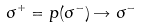Convert formula to latex. <formula><loc_0><loc_0><loc_500><loc_500>\, \sigma ^ { + } = p ( \sigma ^ { - } ) \rightarrow \sigma ^ { - } \,</formula> 